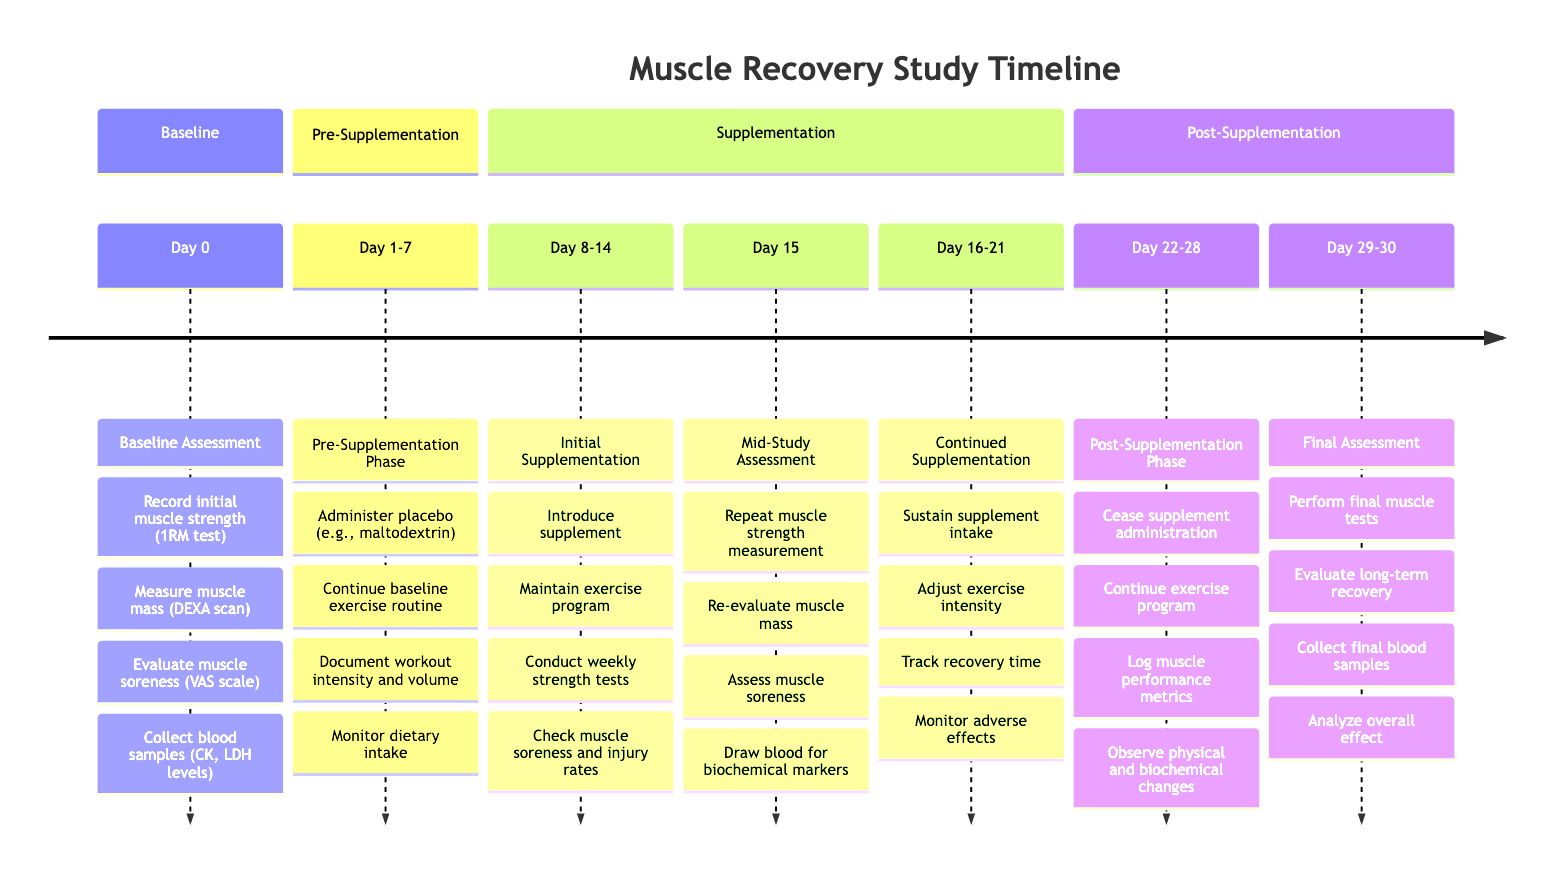What is the first stage of the timeline? The timeline starts with the "Baseline Assessment" stage, which is labeled clearly at the beginning of the timeline.
Answer: Baseline Assessment How many days does the Pre-Supplementation Phase last? The Pre-Supplementation Phase is indicated to last from Day 1 to Day 7, which totals 7 days.
Answer: 7 days What activities are performed during the Initial Supplementation stage? The activities include introducing a supplement, maintaining the exercise program, conducting weekly strength tests, and checking muscle soreness and injury rates, which are listed under the Initial Supplementation stage.
Answer: Introduce supplement, maintain exercise program, conduct weekly strength tests, check muscle soreness and injury rates On what day is the Mid-Study Assessment conducted? The Mid-Study Assessment is specifically mentioned to occur on Day 15, marked as a distinct point in the timeline.
Answer: Day 15 What follows the Continued Supplementation stage? After the Continued Supplementation stage (Day 16-21), the timeline specifies the Post-Supplementation Phase, which begins on Day 22.
Answer: Post-Supplementation Phase What is the purpose of the Final Assessment stage? The Final Assessment stage includes performing final muscle strength and mass tests, evaluating long-term muscle recovery, collecting final blood samples, and analyzing the overall effect of supplementation, indicating a comprehensive assessment.
Answer: Perform final muscle strength and mass tests, evaluate long-term muscle recovery, collect final blood samples, analyze overall effect How long is the overall study duration portrayed in the timeline? The timeline notes that the study starts on Day 0 and ends on Day 30, making the overall study duration a total of 30 days.
Answer: 30 days What measurement is repeated during the Mid-Study Assessment? One of the activities during the Mid-Study Assessment is to repeat the muscle strength measurement, making this a key activity in assessing any changes.
Answer: Repeat muscle strength measurement 